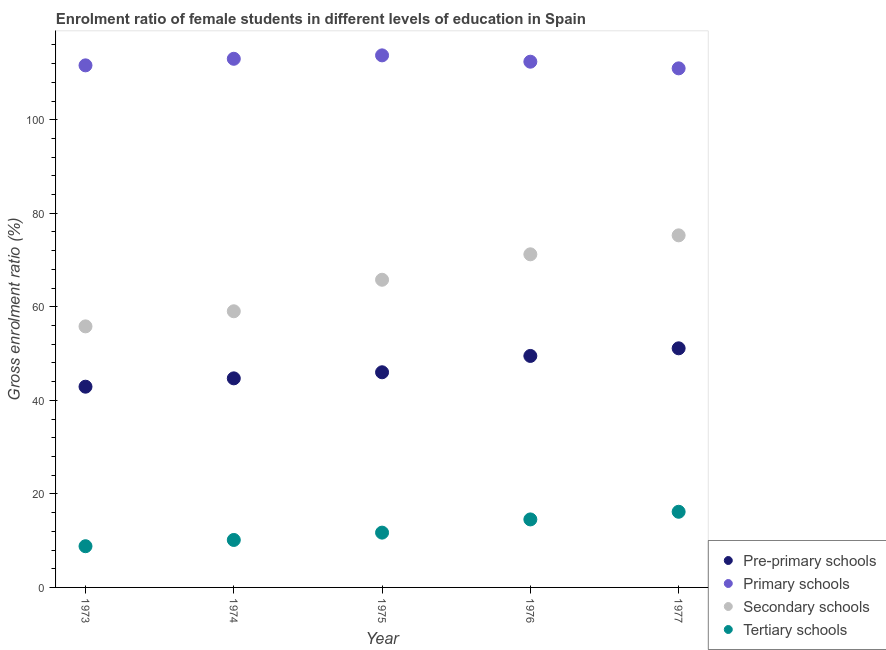How many different coloured dotlines are there?
Give a very brief answer. 4. Is the number of dotlines equal to the number of legend labels?
Provide a succinct answer. Yes. What is the gross enrolment ratio(male) in pre-primary schools in 1974?
Your response must be concise. 44.71. Across all years, what is the maximum gross enrolment ratio(male) in pre-primary schools?
Make the answer very short. 51.13. Across all years, what is the minimum gross enrolment ratio(male) in secondary schools?
Keep it short and to the point. 55.82. In which year was the gross enrolment ratio(male) in primary schools maximum?
Your response must be concise. 1975. In which year was the gross enrolment ratio(male) in pre-primary schools minimum?
Give a very brief answer. 1973. What is the total gross enrolment ratio(male) in pre-primary schools in the graph?
Give a very brief answer. 234.26. What is the difference between the gross enrolment ratio(male) in secondary schools in 1974 and that in 1975?
Your answer should be compact. -6.74. What is the difference between the gross enrolment ratio(male) in tertiary schools in 1974 and the gross enrolment ratio(male) in primary schools in 1977?
Ensure brevity in your answer.  -100.84. What is the average gross enrolment ratio(male) in secondary schools per year?
Make the answer very short. 65.43. In the year 1975, what is the difference between the gross enrolment ratio(male) in primary schools and gross enrolment ratio(male) in tertiary schools?
Ensure brevity in your answer.  102.05. In how many years, is the gross enrolment ratio(male) in secondary schools greater than 52 %?
Give a very brief answer. 5. What is the ratio of the gross enrolment ratio(male) in tertiary schools in 1973 to that in 1977?
Your answer should be compact. 0.54. Is the gross enrolment ratio(male) in pre-primary schools in 1975 less than that in 1976?
Give a very brief answer. Yes. Is the difference between the gross enrolment ratio(male) in pre-primary schools in 1974 and 1977 greater than the difference between the gross enrolment ratio(male) in primary schools in 1974 and 1977?
Provide a succinct answer. No. What is the difference between the highest and the second highest gross enrolment ratio(male) in pre-primary schools?
Your answer should be compact. 1.63. What is the difference between the highest and the lowest gross enrolment ratio(male) in secondary schools?
Keep it short and to the point. 19.46. In how many years, is the gross enrolment ratio(male) in tertiary schools greater than the average gross enrolment ratio(male) in tertiary schools taken over all years?
Give a very brief answer. 2. Is it the case that in every year, the sum of the gross enrolment ratio(male) in pre-primary schools and gross enrolment ratio(male) in primary schools is greater than the gross enrolment ratio(male) in secondary schools?
Provide a short and direct response. Yes. Does the gross enrolment ratio(male) in secondary schools monotonically increase over the years?
Your answer should be compact. Yes. Is the gross enrolment ratio(male) in secondary schools strictly greater than the gross enrolment ratio(male) in pre-primary schools over the years?
Your response must be concise. Yes. Is the gross enrolment ratio(male) in tertiary schools strictly less than the gross enrolment ratio(male) in pre-primary schools over the years?
Keep it short and to the point. Yes. What is the difference between two consecutive major ticks on the Y-axis?
Your answer should be compact. 20. Does the graph contain any zero values?
Your response must be concise. No. Where does the legend appear in the graph?
Your response must be concise. Bottom right. How many legend labels are there?
Ensure brevity in your answer.  4. What is the title of the graph?
Your answer should be compact. Enrolment ratio of female students in different levels of education in Spain. What is the label or title of the Y-axis?
Your response must be concise. Gross enrolment ratio (%). What is the Gross enrolment ratio (%) of Pre-primary schools in 1973?
Keep it short and to the point. 42.92. What is the Gross enrolment ratio (%) of Primary schools in 1973?
Keep it short and to the point. 111.63. What is the Gross enrolment ratio (%) of Secondary schools in 1973?
Your answer should be compact. 55.82. What is the Gross enrolment ratio (%) of Tertiary schools in 1973?
Make the answer very short. 8.81. What is the Gross enrolment ratio (%) in Pre-primary schools in 1974?
Ensure brevity in your answer.  44.71. What is the Gross enrolment ratio (%) of Primary schools in 1974?
Ensure brevity in your answer.  113.04. What is the Gross enrolment ratio (%) in Secondary schools in 1974?
Your answer should be compact. 59.05. What is the Gross enrolment ratio (%) in Tertiary schools in 1974?
Keep it short and to the point. 10.15. What is the Gross enrolment ratio (%) in Pre-primary schools in 1975?
Provide a succinct answer. 46.01. What is the Gross enrolment ratio (%) in Primary schools in 1975?
Your response must be concise. 113.77. What is the Gross enrolment ratio (%) of Secondary schools in 1975?
Provide a short and direct response. 65.79. What is the Gross enrolment ratio (%) in Tertiary schools in 1975?
Provide a succinct answer. 11.72. What is the Gross enrolment ratio (%) in Pre-primary schools in 1976?
Give a very brief answer. 49.5. What is the Gross enrolment ratio (%) in Primary schools in 1976?
Offer a terse response. 112.41. What is the Gross enrolment ratio (%) of Secondary schools in 1976?
Provide a succinct answer. 71.23. What is the Gross enrolment ratio (%) of Tertiary schools in 1976?
Make the answer very short. 14.54. What is the Gross enrolment ratio (%) in Pre-primary schools in 1977?
Offer a very short reply. 51.13. What is the Gross enrolment ratio (%) of Primary schools in 1977?
Your response must be concise. 110.99. What is the Gross enrolment ratio (%) of Secondary schools in 1977?
Provide a short and direct response. 75.28. What is the Gross enrolment ratio (%) of Tertiary schools in 1977?
Provide a succinct answer. 16.18. Across all years, what is the maximum Gross enrolment ratio (%) in Pre-primary schools?
Your response must be concise. 51.13. Across all years, what is the maximum Gross enrolment ratio (%) of Primary schools?
Provide a succinct answer. 113.77. Across all years, what is the maximum Gross enrolment ratio (%) in Secondary schools?
Offer a terse response. 75.28. Across all years, what is the maximum Gross enrolment ratio (%) in Tertiary schools?
Provide a short and direct response. 16.18. Across all years, what is the minimum Gross enrolment ratio (%) in Pre-primary schools?
Your response must be concise. 42.92. Across all years, what is the minimum Gross enrolment ratio (%) in Primary schools?
Your answer should be compact. 110.99. Across all years, what is the minimum Gross enrolment ratio (%) of Secondary schools?
Ensure brevity in your answer.  55.82. Across all years, what is the minimum Gross enrolment ratio (%) in Tertiary schools?
Your answer should be very brief. 8.81. What is the total Gross enrolment ratio (%) in Pre-primary schools in the graph?
Make the answer very short. 234.26. What is the total Gross enrolment ratio (%) in Primary schools in the graph?
Give a very brief answer. 561.84. What is the total Gross enrolment ratio (%) in Secondary schools in the graph?
Make the answer very short. 327.17. What is the total Gross enrolment ratio (%) of Tertiary schools in the graph?
Make the answer very short. 61.4. What is the difference between the Gross enrolment ratio (%) of Pre-primary schools in 1973 and that in 1974?
Make the answer very short. -1.78. What is the difference between the Gross enrolment ratio (%) in Primary schools in 1973 and that in 1974?
Offer a very short reply. -1.4. What is the difference between the Gross enrolment ratio (%) in Secondary schools in 1973 and that in 1974?
Your answer should be very brief. -3.23. What is the difference between the Gross enrolment ratio (%) of Tertiary schools in 1973 and that in 1974?
Your answer should be compact. -1.34. What is the difference between the Gross enrolment ratio (%) of Pre-primary schools in 1973 and that in 1975?
Provide a succinct answer. -3.08. What is the difference between the Gross enrolment ratio (%) in Primary schools in 1973 and that in 1975?
Offer a terse response. -2.14. What is the difference between the Gross enrolment ratio (%) in Secondary schools in 1973 and that in 1975?
Ensure brevity in your answer.  -9.97. What is the difference between the Gross enrolment ratio (%) in Tertiary schools in 1973 and that in 1975?
Keep it short and to the point. -2.91. What is the difference between the Gross enrolment ratio (%) of Pre-primary schools in 1973 and that in 1976?
Ensure brevity in your answer.  -6.58. What is the difference between the Gross enrolment ratio (%) in Primary schools in 1973 and that in 1976?
Ensure brevity in your answer.  -0.78. What is the difference between the Gross enrolment ratio (%) in Secondary schools in 1973 and that in 1976?
Your answer should be compact. -15.41. What is the difference between the Gross enrolment ratio (%) in Tertiary schools in 1973 and that in 1976?
Your answer should be very brief. -5.73. What is the difference between the Gross enrolment ratio (%) of Pre-primary schools in 1973 and that in 1977?
Ensure brevity in your answer.  -8.21. What is the difference between the Gross enrolment ratio (%) of Primary schools in 1973 and that in 1977?
Offer a terse response. 0.64. What is the difference between the Gross enrolment ratio (%) in Secondary schools in 1973 and that in 1977?
Give a very brief answer. -19.46. What is the difference between the Gross enrolment ratio (%) in Tertiary schools in 1973 and that in 1977?
Ensure brevity in your answer.  -7.37. What is the difference between the Gross enrolment ratio (%) of Pre-primary schools in 1974 and that in 1975?
Your answer should be compact. -1.3. What is the difference between the Gross enrolment ratio (%) of Primary schools in 1974 and that in 1975?
Give a very brief answer. -0.73. What is the difference between the Gross enrolment ratio (%) of Secondary schools in 1974 and that in 1975?
Your answer should be compact. -6.74. What is the difference between the Gross enrolment ratio (%) in Tertiary schools in 1974 and that in 1975?
Provide a short and direct response. -1.57. What is the difference between the Gross enrolment ratio (%) in Pre-primary schools in 1974 and that in 1976?
Offer a very short reply. -4.79. What is the difference between the Gross enrolment ratio (%) of Primary schools in 1974 and that in 1976?
Provide a short and direct response. 0.62. What is the difference between the Gross enrolment ratio (%) of Secondary schools in 1974 and that in 1976?
Your response must be concise. -12.18. What is the difference between the Gross enrolment ratio (%) of Tertiary schools in 1974 and that in 1976?
Ensure brevity in your answer.  -4.39. What is the difference between the Gross enrolment ratio (%) in Pre-primary schools in 1974 and that in 1977?
Offer a terse response. -6.42. What is the difference between the Gross enrolment ratio (%) of Primary schools in 1974 and that in 1977?
Offer a terse response. 2.05. What is the difference between the Gross enrolment ratio (%) in Secondary schools in 1974 and that in 1977?
Make the answer very short. -16.24. What is the difference between the Gross enrolment ratio (%) of Tertiary schools in 1974 and that in 1977?
Provide a succinct answer. -6.03. What is the difference between the Gross enrolment ratio (%) of Pre-primary schools in 1975 and that in 1976?
Your answer should be compact. -3.49. What is the difference between the Gross enrolment ratio (%) of Primary schools in 1975 and that in 1976?
Your answer should be compact. 1.35. What is the difference between the Gross enrolment ratio (%) in Secondary schools in 1975 and that in 1976?
Offer a terse response. -5.44. What is the difference between the Gross enrolment ratio (%) in Tertiary schools in 1975 and that in 1976?
Your answer should be very brief. -2.82. What is the difference between the Gross enrolment ratio (%) in Pre-primary schools in 1975 and that in 1977?
Your answer should be very brief. -5.12. What is the difference between the Gross enrolment ratio (%) in Primary schools in 1975 and that in 1977?
Your response must be concise. 2.78. What is the difference between the Gross enrolment ratio (%) of Secondary schools in 1975 and that in 1977?
Keep it short and to the point. -9.5. What is the difference between the Gross enrolment ratio (%) of Tertiary schools in 1975 and that in 1977?
Keep it short and to the point. -4.46. What is the difference between the Gross enrolment ratio (%) in Pre-primary schools in 1976 and that in 1977?
Provide a short and direct response. -1.63. What is the difference between the Gross enrolment ratio (%) in Primary schools in 1976 and that in 1977?
Keep it short and to the point. 1.42. What is the difference between the Gross enrolment ratio (%) in Secondary schools in 1976 and that in 1977?
Your response must be concise. -4.06. What is the difference between the Gross enrolment ratio (%) in Tertiary schools in 1976 and that in 1977?
Provide a short and direct response. -1.64. What is the difference between the Gross enrolment ratio (%) in Pre-primary schools in 1973 and the Gross enrolment ratio (%) in Primary schools in 1974?
Your response must be concise. -70.11. What is the difference between the Gross enrolment ratio (%) of Pre-primary schools in 1973 and the Gross enrolment ratio (%) of Secondary schools in 1974?
Your answer should be very brief. -16.13. What is the difference between the Gross enrolment ratio (%) of Pre-primary schools in 1973 and the Gross enrolment ratio (%) of Tertiary schools in 1974?
Your answer should be very brief. 32.77. What is the difference between the Gross enrolment ratio (%) in Primary schools in 1973 and the Gross enrolment ratio (%) in Secondary schools in 1974?
Make the answer very short. 52.58. What is the difference between the Gross enrolment ratio (%) in Primary schools in 1973 and the Gross enrolment ratio (%) in Tertiary schools in 1974?
Offer a terse response. 101.48. What is the difference between the Gross enrolment ratio (%) of Secondary schools in 1973 and the Gross enrolment ratio (%) of Tertiary schools in 1974?
Make the answer very short. 45.67. What is the difference between the Gross enrolment ratio (%) of Pre-primary schools in 1973 and the Gross enrolment ratio (%) of Primary schools in 1975?
Offer a terse response. -70.85. What is the difference between the Gross enrolment ratio (%) of Pre-primary schools in 1973 and the Gross enrolment ratio (%) of Secondary schools in 1975?
Give a very brief answer. -22.86. What is the difference between the Gross enrolment ratio (%) in Pre-primary schools in 1973 and the Gross enrolment ratio (%) in Tertiary schools in 1975?
Give a very brief answer. 31.2. What is the difference between the Gross enrolment ratio (%) of Primary schools in 1973 and the Gross enrolment ratio (%) of Secondary schools in 1975?
Give a very brief answer. 45.85. What is the difference between the Gross enrolment ratio (%) in Primary schools in 1973 and the Gross enrolment ratio (%) in Tertiary schools in 1975?
Keep it short and to the point. 99.92. What is the difference between the Gross enrolment ratio (%) in Secondary schools in 1973 and the Gross enrolment ratio (%) in Tertiary schools in 1975?
Your answer should be very brief. 44.1. What is the difference between the Gross enrolment ratio (%) in Pre-primary schools in 1973 and the Gross enrolment ratio (%) in Primary schools in 1976?
Your response must be concise. -69.49. What is the difference between the Gross enrolment ratio (%) in Pre-primary schools in 1973 and the Gross enrolment ratio (%) in Secondary schools in 1976?
Offer a terse response. -28.31. What is the difference between the Gross enrolment ratio (%) in Pre-primary schools in 1973 and the Gross enrolment ratio (%) in Tertiary schools in 1976?
Your answer should be very brief. 28.38. What is the difference between the Gross enrolment ratio (%) of Primary schools in 1973 and the Gross enrolment ratio (%) of Secondary schools in 1976?
Offer a very short reply. 40.4. What is the difference between the Gross enrolment ratio (%) of Primary schools in 1973 and the Gross enrolment ratio (%) of Tertiary schools in 1976?
Provide a succinct answer. 97.09. What is the difference between the Gross enrolment ratio (%) in Secondary schools in 1973 and the Gross enrolment ratio (%) in Tertiary schools in 1976?
Offer a very short reply. 41.28. What is the difference between the Gross enrolment ratio (%) in Pre-primary schools in 1973 and the Gross enrolment ratio (%) in Primary schools in 1977?
Keep it short and to the point. -68.07. What is the difference between the Gross enrolment ratio (%) in Pre-primary schools in 1973 and the Gross enrolment ratio (%) in Secondary schools in 1977?
Ensure brevity in your answer.  -32.36. What is the difference between the Gross enrolment ratio (%) of Pre-primary schools in 1973 and the Gross enrolment ratio (%) of Tertiary schools in 1977?
Provide a short and direct response. 26.74. What is the difference between the Gross enrolment ratio (%) in Primary schools in 1973 and the Gross enrolment ratio (%) in Secondary schools in 1977?
Keep it short and to the point. 36.35. What is the difference between the Gross enrolment ratio (%) of Primary schools in 1973 and the Gross enrolment ratio (%) of Tertiary schools in 1977?
Your answer should be compact. 95.46. What is the difference between the Gross enrolment ratio (%) in Secondary schools in 1973 and the Gross enrolment ratio (%) in Tertiary schools in 1977?
Ensure brevity in your answer.  39.64. What is the difference between the Gross enrolment ratio (%) in Pre-primary schools in 1974 and the Gross enrolment ratio (%) in Primary schools in 1975?
Keep it short and to the point. -69.06. What is the difference between the Gross enrolment ratio (%) of Pre-primary schools in 1974 and the Gross enrolment ratio (%) of Secondary schools in 1975?
Ensure brevity in your answer.  -21.08. What is the difference between the Gross enrolment ratio (%) in Pre-primary schools in 1974 and the Gross enrolment ratio (%) in Tertiary schools in 1975?
Your answer should be compact. 32.99. What is the difference between the Gross enrolment ratio (%) of Primary schools in 1974 and the Gross enrolment ratio (%) of Secondary schools in 1975?
Give a very brief answer. 47.25. What is the difference between the Gross enrolment ratio (%) in Primary schools in 1974 and the Gross enrolment ratio (%) in Tertiary schools in 1975?
Offer a very short reply. 101.32. What is the difference between the Gross enrolment ratio (%) in Secondary schools in 1974 and the Gross enrolment ratio (%) in Tertiary schools in 1975?
Offer a terse response. 47.33. What is the difference between the Gross enrolment ratio (%) in Pre-primary schools in 1974 and the Gross enrolment ratio (%) in Primary schools in 1976?
Provide a succinct answer. -67.71. What is the difference between the Gross enrolment ratio (%) of Pre-primary schools in 1974 and the Gross enrolment ratio (%) of Secondary schools in 1976?
Your answer should be very brief. -26.52. What is the difference between the Gross enrolment ratio (%) of Pre-primary schools in 1974 and the Gross enrolment ratio (%) of Tertiary schools in 1976?
Make the answer very short. 30.16. What is the difference between the Gross enrolment ratio (%) of Primary schools in 1974 and the Gross enrolment ratio (%) of Secondary schools in 1976?
Ensure brevity in your answer.  41.81. What is the difference between the Gross enrolment ratio (%) of Primary schools in 1974 and the Gross enrolment ratio (%) of Tertiary schools in 1976?
Your answer should be compact. 98.49. What is the difference between the Gross enrolment ratio (%) of Secondary schools in 1974 and the Gross enrolment ratio (%) of Tertiary schools in 1976?
Give a very brief answer. 44.51. What is the difference between the Gross enrolment ratio (%) in Pre-primary schools in 1974 and the Gross enrolment ratio (%) in Primary schools in 1977?
Your answer should be very brief. -66.29. What is the difference between the Gross enrolment ratio (%) of Pre-primary schools in 1974 and the Gross enrolment ratio (%) of Secondary schools in 1977?
Your answer should be very brief. -30.58. What is the difference between the Gross enrolment ratio (%) of Pre-primary schools in 1974 and the Gross enrolment ratio (%) of Tertiary schools in 1977?
Your answer should be very brief. 28.53. What is the difference between the Gross enrolment ratio (%) in Primary schools in 1974 and the Gross enrolment ratio (%) in Secondary schools in 1977?
Your answer should be very brief. 37.75. What is the difference between the Gross enrolment ratio (%) in Primary schools in 1974 and the Gross enrolment ratio (%) in Tertiary schools in 1977?
Offer a very short reply. 96.86. What is the difference between the Gross enrolment ratio (%) in Secondary schools in 1974 and the Gross enrolment ratio (%) in Tertiary schools in 1977?
Ensure brevity in your answer.  42.87. What is the difference between the Gross enrolment ratio (%) in Pre-primary schools in 1975 and the Gross enrolment ratio (%) in Primary schools in 1976?
Your answer should be compact. -66.41. What is the difference between the Gross enrolment ratio (%) of Pre-primary schools in 1975 and the Gross enrolment ratio (%) of Secondary schools in 1976?
Your answer should be compact. -25.22. What is the difference between the Gross enrolment ratio (%) of Pre-primary schools in 1975 and the Gross enrolment ratio (%) of Tertiary schools in 1976?
Make the answer very short. 31.46. What is the difference between the Gross enrolment ratio (%) of Primary schools in 1975 and the Gross enrolment ratio (%) of Secondary schools in 1976?
Keep it short and to the point. 42.54. What is the difference between the Gross enrolment ratio (%) in Primary schools in 1975 and the Gross enrolment ratio (%) in Tertiary schools in 1976?
Your answer should be compact. 99.23. What is the difference between the Gross enrolment ratio (%) of Secondary schools in 1975 and the Gross enrolment ratio (%) of Tertiary schools in 1976?
Ensure brevity in your answer.  51.25. What is the difference between the Gross enrolment ratio (%) in Pre-primary schools in 1975 and the Gross enrolment ratio (%) in Primary schools in 1977?
Keep it short and to the point. -64.98. What is the difference between the Gross enrolment ratio (%) in Pre-primary schools in 1975 and the Gross enrolment ratio (%) in Secondary schools in 1977?
Offer a very short reply. -29.28. What is the difference between the Gross enrolment ratio (%) in Pre-primary schools in 1975 and the Gross enrolment ratio (%) in Tertiary schools in 1977?
Provide a short and direct response. 29.83. What is the difference between the Gross enrolment ratio (%) in Primary schools in 1975 and the Gross enrolment ratio (%) in Secondary schools in 1977?
Give a very brief answer. 38.48. What is the difference between the Gross enrolment ratio (%) in Primary schools in 1975 and the Gross enrolment ratio (%) in Tertiary schools in 1977?
Your response must be concise. 97.59. What is the difference between the Gross enrolment ratio (%) of Secondary schools in 1975 and the Gross enrolment ratio (%) of Tertiary schools in 1977?
Ensure brevity in your answer.  49.61. What is the difference between the Gross enrolment ratio (%) in Pre-primary schools in 1976 and the Gross enrolment ratio (%) in Primary schools in 1977?
Your answer should be very brief. -61.49. What is the difference between the Gross enrolment ratio (%) in Pre-primary schools in 1976 and the Gross enrolment ratio (%) in Secondary schools in 1977?
Your answer should be compact. -25.79. What is the difference between the Gross enrolment ratio (%) of Pre-primary schools in 1976 and the Gross enrolment ratio (%) of Tertiary schools in 1977?
Provide a short and direct response. 33.32. What is the difference between the Gross enrolment ratio (%) in Primary schools in 1976 and the Gross enrolment ratio (%) in Secondary schools in 1977?
Keep it short and to the point. 37.13. What is the difference between the Gross enrolment ratio (%) of Primary schools in 1976 and the Gross enrolment ratio (%) of Tertiary schools in 1977?
Offer a terse response. 96.24. What is the difference between the Gross enrolment ratio (%) of Secondary schools in 1976 and the Gross enrolment ratio (%) of Tertiary schools in 1977?
Your response must be concise. 55.05. What is the average Gross enrolment ratio (%) in Pre-primary schools per year?
Keep it short and to the point. 46.85. What is the average Gross enrolment ratio (%) in Primary schools per year?
Ensure brevity in your answer.  112.37. What is the average Gross enrolment ratio (%) of Secondary schools per year?
Your answer should be compact. 65.43. What is the average Gross enrolment ratio (%) of Tertiary schools per year?
Your answer should be very brief. 12.28. In the year 1973, what is the difference between the Gross enrolment ratio (%) of Pre-primary schools and Gross enrolment ratio (%) of Primary schools?
Your answer should be very brief. -68.71. In the year 1973, what is the difference between the Gross enrolment ratio (%) in Pre-primary schools and Gross enrolment ratio (%) in Secondary schools?
Offer a terse response. -12.9. In the year 1973, what is the difference between the Gross enrolment ratio (%) of Pre-primary schools and Gross enrolment ratio (%) of Tertiary schools?
Your response must be concise. 34.11. In the year 1973, what is the difference between the Gross enrolment ratio (%) in Primary schools and Gross enrolment ratio (%) in Secondary schools?
Your answer should be compact. 55.81. In the year 1973, what is the difference between the Gross enrolment ratio (%) of Primary schools and Gross enrolment ratio (%) of Tertiary schools?
Provide a short and direct response. 102.82. In the year 1973, what is the difference between the Gross enrolment ratio (%) in Secondary schools and Gross enrolment ratio (%) in Tertiary schools?
Your answer should be very brief. 47.01. In the year 1974, what is the difference between the Gross enrolment ratio (%) in Pre-primary schools and Gross enrolment ratio (%) in Primary schools?
Offer a terse response. -68.33. In the year 1974, what is the difference between the Gross enrolment ratio (%) in Pre-primary schools and Gross enrolment ratio (%) in Secondary schools?
Give a very brief answer. -14.34. In the year 1974, what is the difference between the Gross enrolment ratio (%) in Pre-primary schools and Gross enrolment ratio (%) in Tertiary schools?
Provide a succinct answer. 34.55. In the year 1974, what is the difference between the Gross enrolment ratio (%) in Primary schools and Gross enrolment ratio (%) in Secondary schools?
Make the answer very short. 53.99. In the year 1974, what is the difference between the Gross enrolment ratio (%) of Primary schools and Gross enrolment ratio (%) of Tertiary schools?
Ensure brevity in your answer.  102.89. In the year 1974, what is the difference between the Gross enrolment ratio (%) of Secondary schools and Gross enrolment ratio (%) of Tertiary schools?
Ensure brevity in your answer.  48.9. In the year 1975, what is the difference between the Gross enrolment ratio (%) in Pre-primary schools and Gross enrolment ratio (%) in Primary schools?
Provide a succinct answer. -67.76. In the year 1975, what is the difference between the Gross enrolment ratio (%) of Pre-primary schools and Gross enrolment ratio (%) of Secondary schools?
Your answer should be very brief. -19.78. In the year 1975, what is the difference between the Gross enrolment ratio (%) in Pre-primary schools and Gross enrolment ratio (%) in Tertiary schools?
Provide a succinct answer. 34.29. In the year 1975, what is the difference between the Gross enrolment ratio (%) of Primary schools and Gross enrolment ratio (%) of Secondary schools?
Give a very brief answer. 47.98. In the year 1975, what is the difference between the Gross enrolment ratio (%) in Primary schools and Gross enrolment ratio (%) in Tertiary schools?
Ensure brevity in your answer.  102.05. In the year 1975, what is the difference between the Gross enrolment ratio (%) of Secondary schools and Gross enrolment ratio (%) of Tertiary schools?
Keep it short and to the point. 54.07. In the year 1976, what is the difference between the Gross enrolment ratio (%) in Pre-primary schools and Gross enrolment ratio (%) in Primary schools?
Ensure brevity in your answer.  -62.92. In the year 1976, what is the difference between the Gross enrolment ratio (%) in Pre-primary schools and Gross enrolment ratio (%) in Secondary schools?
Your answer should be very brief. -21.73. In the year 1976, what is the difference between the Gross enrolment ratio (%) in Pre-primary schools and Gross enrolment ratio (%) in Tertiary schools?
Provide a short and direct response. 34.96. In the year 1976, what is the difference between the Gross enrolment ratio (%) of Primary schools and Gross enrolment ratio (%) of Secondary schools?
Your response must be concise. 41.19. In the year 1976, what is the difference between the Gross enrolment ratio (%) of Primary schools and Gross enrolment ratio (%) of Tertiary schools?
Keep it short and to the point. 97.87. In the year 1976, what is the difference between the Gross enrolment ratio (%) of Secondary schools and Gross enrolment ratio (%) of Tertiary schools?
Give a very brief answer. 56.69. In the year 1977, what is the difference between the Gross enrolment ratio (%) of Pre-primary schools and Gross enrolment ratio (%) of Primary schools?
Offer a very short reply. -59.86. In the year 1977, what is the difference between the Gross enrolment ratio (%) in Pre-primary schools and Gross enrolment ratio (%) in Secondary schools?
Ensure brevity in your answer.  -24.16. In the year 1977, what is the difference between the Gross enrolment ratio (%) in Pre-primary schools and Gross enrolment ratio (%) in Tertiary schools?
Your answer should be very brief. 34.95. In the year 1977, what is the difference between the Gross enrolment ratio (%) of Primary schools and Gross enrolment ratio (%) of Secondary schools?
Offer a very short reply. 35.71. In the year 1977, what is the difference between the Gross enrolment ratio (%) in Primary schools and Gross enrolment ratio (%) in Tertiary schools?
Ensure brevity in your answer.  94.81. In the year 1977, what is the difference between the Gross enrolment ratio (%) in Secondary schools and Gross enrolment ratio (%) in Tertiary schools?
Ensure brevity in your answer.  59.11. What is the ratio of the Gross enrolment ratio (%) of Pre-primary schools in 1973 to that in 1974?
Keep it short and to the point. 0.96. What is the ratio of the Gross enrolment ratio (%) of Primary schools in 1973 to that in 1974?
Make the answer very short. 0.99. What is the ratio of the Gross enrolment ratio (%) in Secondary schools in 1973 to that in 1974?
Your answer should be compact. 0.95. What is the ratio of the Gross enrolment ratio (%) of Tertiary schools in 1973 to that in 1974?
Provide a succinct answer. 0.87. What is the ratio of the Gross enrolment ratio (%) in Pre-primary schools in 1973 to that in 1975?
Offer a very short reply. 0.93. What is the ratio of the Gross enrolment ratio (%) of Primary schools in 1973 to that in 1975?
Ensure brevity in your answer.  0.98. What is the ratio of the Gross enrolment ratio (%) in Secondary schools in 1973 to that in 1975?
Your response must be concise. 0.85. What is the ratio of the Gross enrolment ratio (%) in Tertiary schools in 1973 to that in 1975?
Give a very brief answer. 0.75. What is the ratio of the Gross enrolment ratio (%) of Pre-primary schools in 1973 to that in 1976?
Offer a very short reply. 0.87. What is the ratio of the Gross enrolment ratio (%) of Primary schools in 1973 to that in 1976?
Your answer should be very brief. 0.99. What is the ratio of the Gross enrolment ratio (%) of Secondary schools in 1973 to that in 1976?
Ensure brevity in your answer.  0.78. What is the ratio of the Gross enrolment ratio (%) of Tertiary schools in 1973 to that in 1976?
Give a very brief answer. 0.61. What is the ratio of the Gross enrolment ratio (%) of Pre-primary schools in 1973 to that in 1977?
Offer a very short reply. 0.84. What is the ratio of the Gross enrolment ratio (%) of Primary schools in 1973 to that in 1977?
Give a very brief answer. 1.01. What is the ratio of the Gross enrolment ratio (%) in Secondary schools in 1973 to that in 1977?
Provide a short and direct response. 0.74. What is the ratio of the Gross enrolment ratio (%) in Tertiary schools in 1973 to that in 1977?
Your answer should be very brief. 0.54. What is the ratio of the Gross enrolment ratio (%) in Pre-primary schools in 1974 to that in 1975?
Your response must be concise. 0.97. What is the ratio of the Gross enrolment ratio (%) in Secondary schools in 1974 to that in 1975?
Offer a very short reply. 0.9. What is the ratio of the Gross enrolment ratio (%) in Tertiary schools in 1974 to that in 1975?
Your answer should be very brief. 0.87. What is the ratio of the Gross enrolment ratio (%) of Pre-primary schools in 1974 to that in 1976?
Your answer should be very brief. 0.9. What is the ratio of the Gross enrolment ratio (%) of Secondary schools in 1974 to that in 1976?
Give a very brief answer. 0.83. What is the ratio of the Gross enrolment ratio (%) of Tertiary schools in 1974 to that in 1976?
Give a very brief answer. 0.7. What is the ratio of the Gross enrolment ratio (%) of Pre-primary schools in 1974 to that in 1977?
Your answer should be compact. 0.87. What is the ratio of the Gross enrolment ratio (%) in Primary schools in 1974 to that in 1977?
Provide a short and direct response. 1.02. What is the ratio of the Gross enrolment ratio (%) of Secondary schools in 1974 to that in 1977?
Your answer should be compact. 0.78. What is the ratio of the Gross enrolment ratio (%) in Tertiary schools in 1974 to that in 1977?
Provide a short and direct response. 0.63. What is the ratio of the Gross enrolment ratio (%) in Pre-primary schools in 1975 to that in 1976?
Your answer should be very brief. 0.93. What is the ratio of the Gross enrolment ratio (%) in Secondary schools in 1975 to that in 1976?
Offer a very short reply. 0.92. What is the ratio of the Gross enrolment ratio (%) in Tertiary schools in 1975 to that in 1976?
Your response must be concise. 0.81. What is the ratio of the Gross enrolment ratio (%) of Pre-primary schools in 1975 to that in 1977?
Make the answer very short. 0.9. What is the ratio of the Gross enrolment ratio (%) in Primary schools in 1975 to that in 1977?
Keep it short and to the point. 1.02. What is the ratio of the Gross enrolment ratio (%) of Secondary schools in 1975 to that in 1977?
Offer a very short reply. 0.87. What is the ratio of the Gross enrolment ratio (%) of Tertiary schools in 1975 to that in 1977?
Provide a succinct answer. 0.72. What is the ratio of the Gross enrolment ratio (%) of Pre-primary schools in 1976 to that in 1977?
Give a very brief answer. 0.97. What is the ratio of the Gross enrolment ratio (%) in Primary schools in 1976 to that in 1977?
Your response must be concise. 1.01. What is the ratio of the Gross enrolment ratio (%) of Secondary schools in 1976 to that in 1977?
Keep it short and to the point. 0.95. What is the ratio of the Gross enrolment ratio (%) of Tertiary schools in 1976 to that in 1977?
Your answer should be very brief. 0.9. What is the difference between the highest and the second highest Gross enrolment ratio (%) in Pre-primary schools?
Keep it short and to the point. 1.63. What is the difference between the highest and the second highest Gross enrolment ratio (%) of Primary schools?
Provide a short and direct response. 0.73. What is the difference between the highest and the second highest Gross enrolment ratio (%) of Secondary schools?
Provide a succinct answer. 4.06. What is the difference between the highest and the second highest Gross enrolment ratio (%) in Tertiary schools?
Offer a very short reply. 1.64. What is the difference between the highest and the lowest Gross enrolment ratio (%) of Pre-primary schools?
Keep it short and to the point. 8.21. What is the difference between the highest and the lowest Gross enrolment ratio (%) in Primary schools?
Your response must be concise. 2.78. What is the difference between the highest and the lowest Gross enrolment ratio (%) of Secondary schools?
Give a very brief answer. 19.46. What is the difference between the highest and the lowest Gross enrolment ratio (%) of Tertiary schools?
Ensure brevity in your answer.  7.37. 